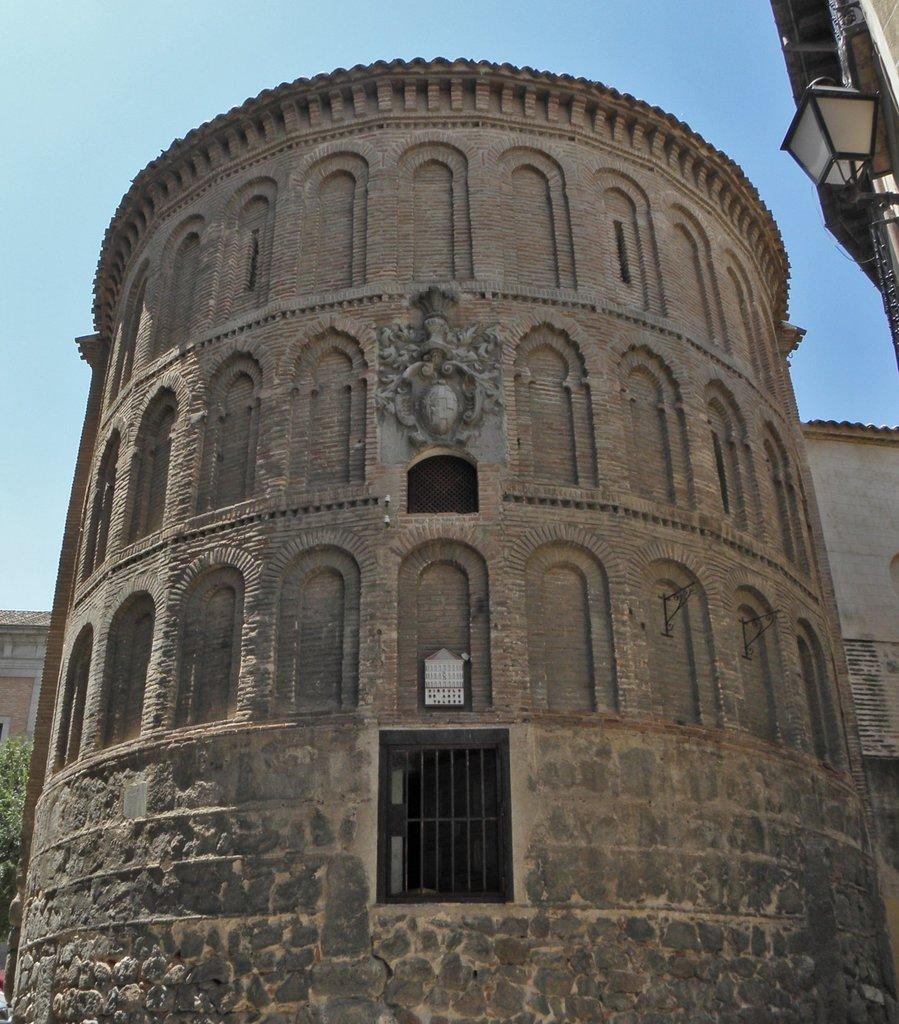What type of structure is in the image? There is a fort in the image. What feature can be seen on the fort? The fort has a window. What is located near the window? There are iron rods visible near the window. What is to the right of the window? There is a light to the right of the window. What can be seen in the background of the image? There is a tree and the sky visible in the background of the image. What discovery was made by the achiever in the image? There is no achiever or discovery mentioned in the image; it only features a fort with a window, iron rods, a light, a tree, and the sky. 